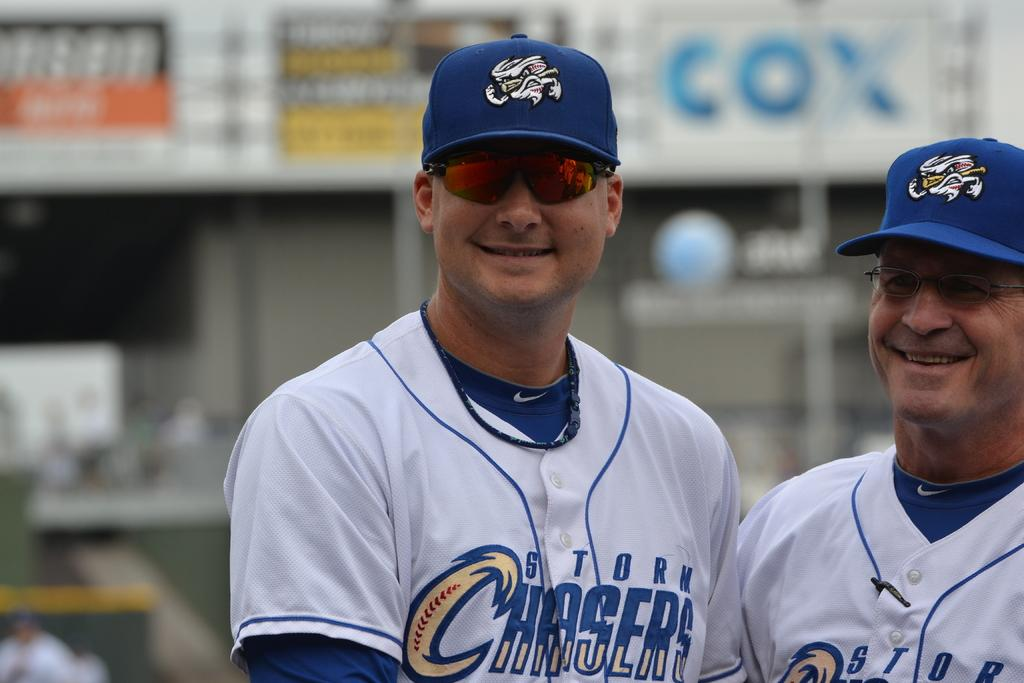<image>
Give a short and clear explanation of the subsequent image. Two personnel for the Chasers baseball team are smiling. 